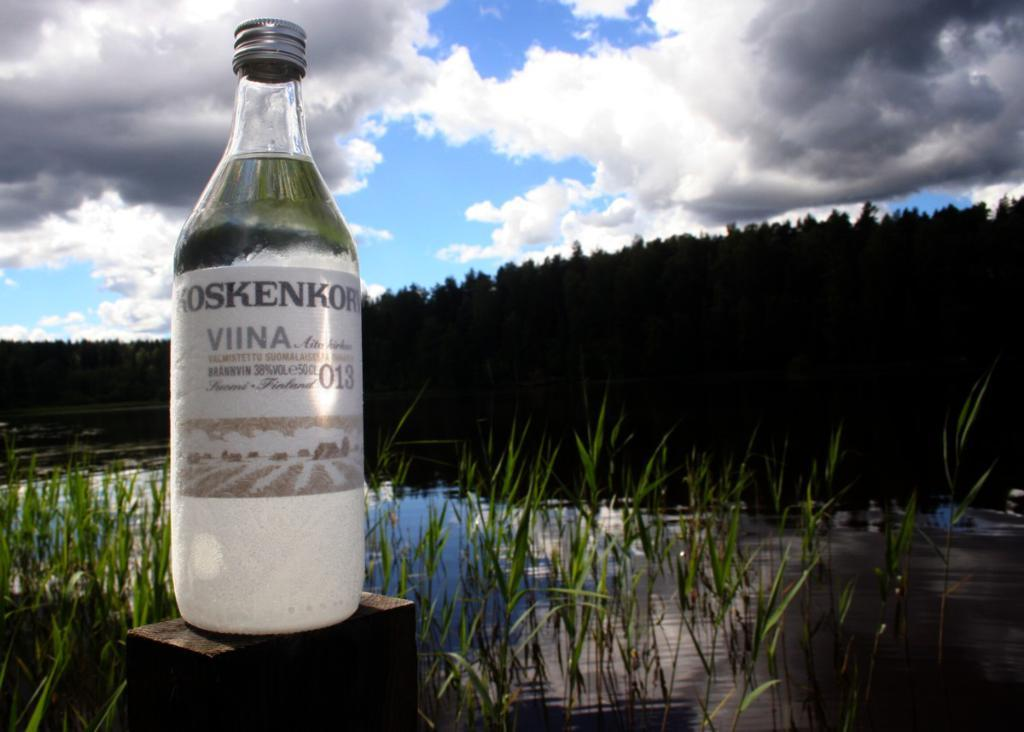What object can be seen in the image that is typically used for holding liquids? There is a bottle in the image that is typically used for holding liquids. What type of living organisms are present in the image? There are plants in the image. What is the liquid substance visible in the image? There is water in the image. What can be seen in the background of the image? A: The sky is visible in the background of the image. Where is the stamp located in the image? There is no stamp present in the image. What type of stem can be seen growing from the plants in the image? The image does not show any stems growing from the plants, as it only shows the plants themselves. 